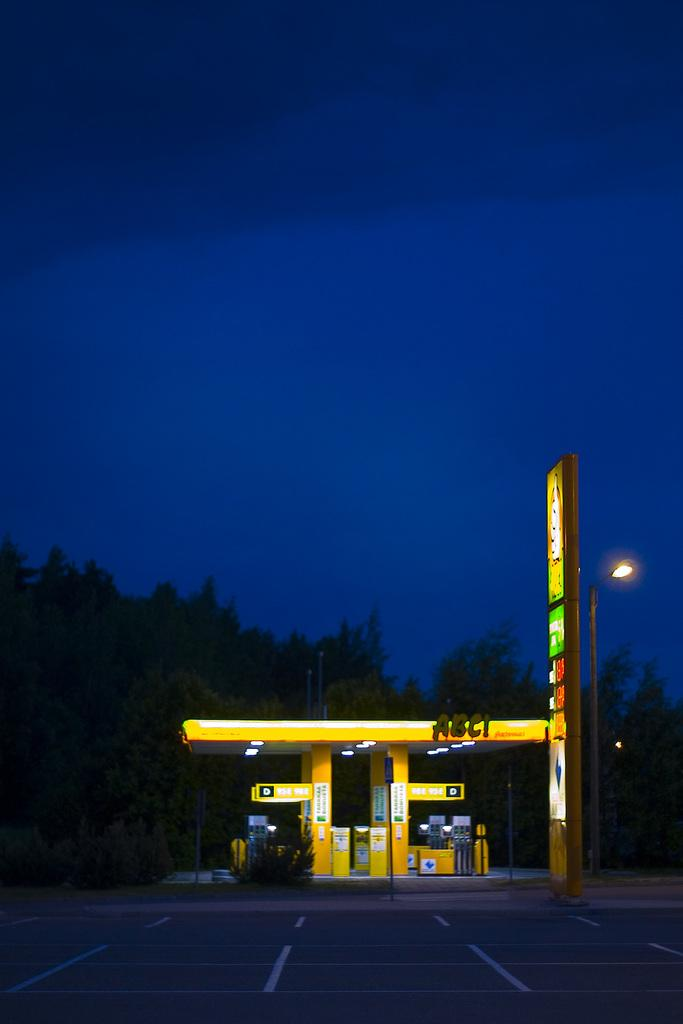<image>
Offer a succinct explanation of the picture presented. An ABC gas station as is surrounded by an empty parking lot. 